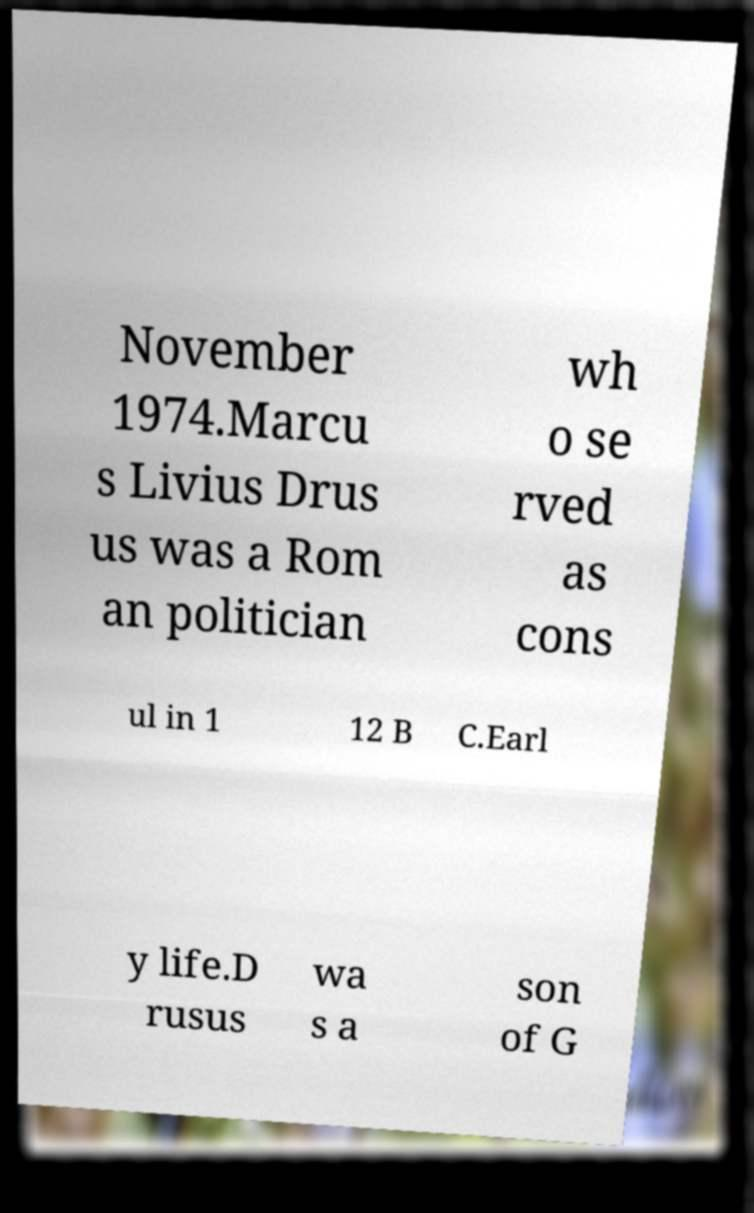Could you extract and type out the text from this image? November 1974.Marcu s Livius Drus us was a Rom an politician wh o se rved as cons ul in 1 12 B C.Earl y life.D rusus wa s a son of G 